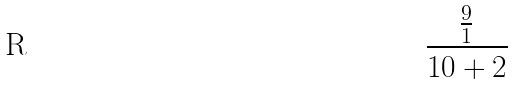Convert formula to latex. <formula><loc_0><loc_0><loc_500><loc_500>\frac { \frac { 9 } { 1 } } { 1 0 + 2 }</formula> 